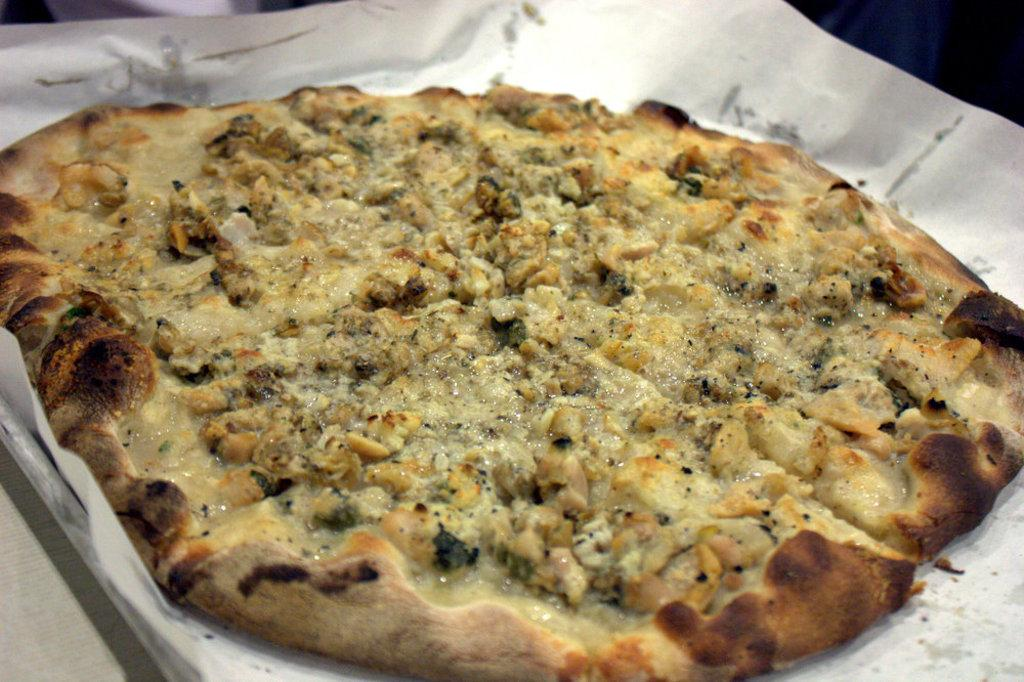What type of food is shown in the image? There is a pizza in the image. How is the pizza presented? The pizza is on a plate. Where is the plate with the pizza located? The plate with the pizza is placed on a table. What type of berry can be seen in the bucket in the image? There is no berry or bucket present in the image; it only features a pizza on a plate placed on a table. 